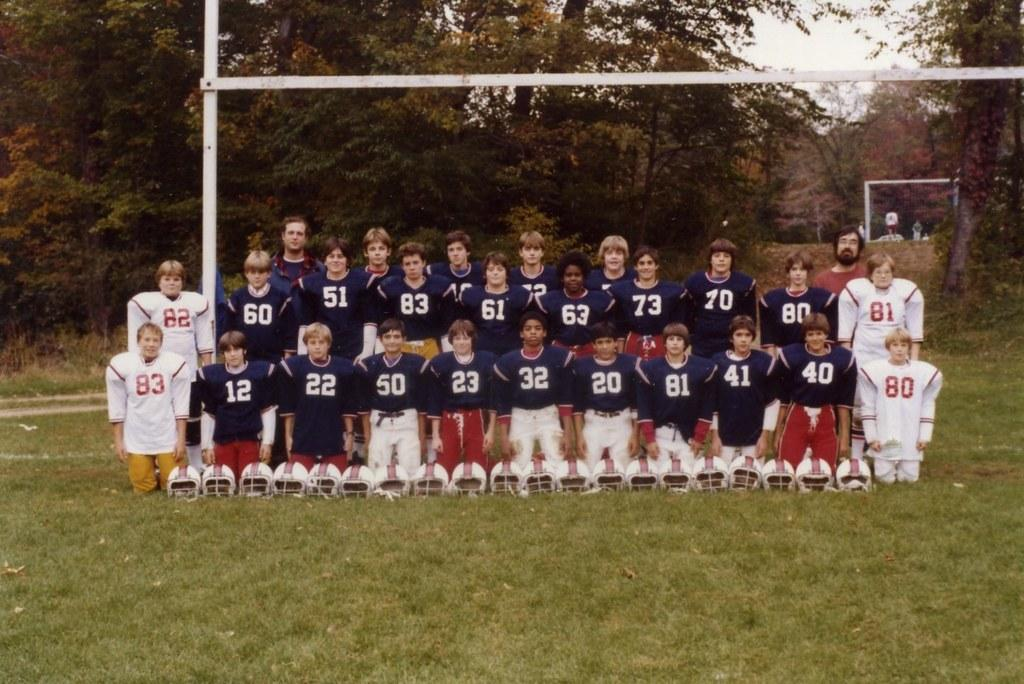<image>
Describe the image concisely. A boy with red pants and the number twenty three on his shirt. 